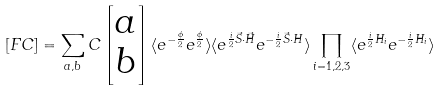Convert formula to latex. <formula><loc_0><loc_0><loc_500><loc_500>[ F C ] = \sum _ { a , b } C \begin{bmatrix} a \\ b \end{bmatrix} \langle e ^ { - \frac { \phi } { 2 } } e ^ { \frac { \phi } { 2 } } \rangle \langle e ^ { \frac { i } { 2 } \vec { S } \cdot \vec { H } } e ^ { - \frac { i } { 2 } \vec { S } \cdot H } \rangle \prod _ { i = 1 , 2 , 3 } \langle e ^ { \frac { i } { 2 } H _ { i } } e ^ { - \frac { i } { 2 } H _ { i } } \rangle</formula> 